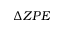Convert formula to latex. <formula><loc_0><loc_0><loc_500><loc_500>\Delta Z P E</formula> 